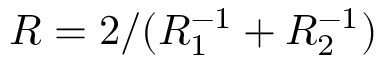<formula> <loc_0><loc_0><loc_500><loc_500>R = 2 / ( R _ { 1 } ^ { - 1 } + R _ { 2 } ^ { - 1 } )</formula> 